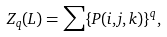Convert formula to latex. <formula><loc_0><loc_0><loc_500><loc_500>Z _ { q } ( L ) = \sum \{ P ( i , j , k ) \} ^ { q } ,</formula> 